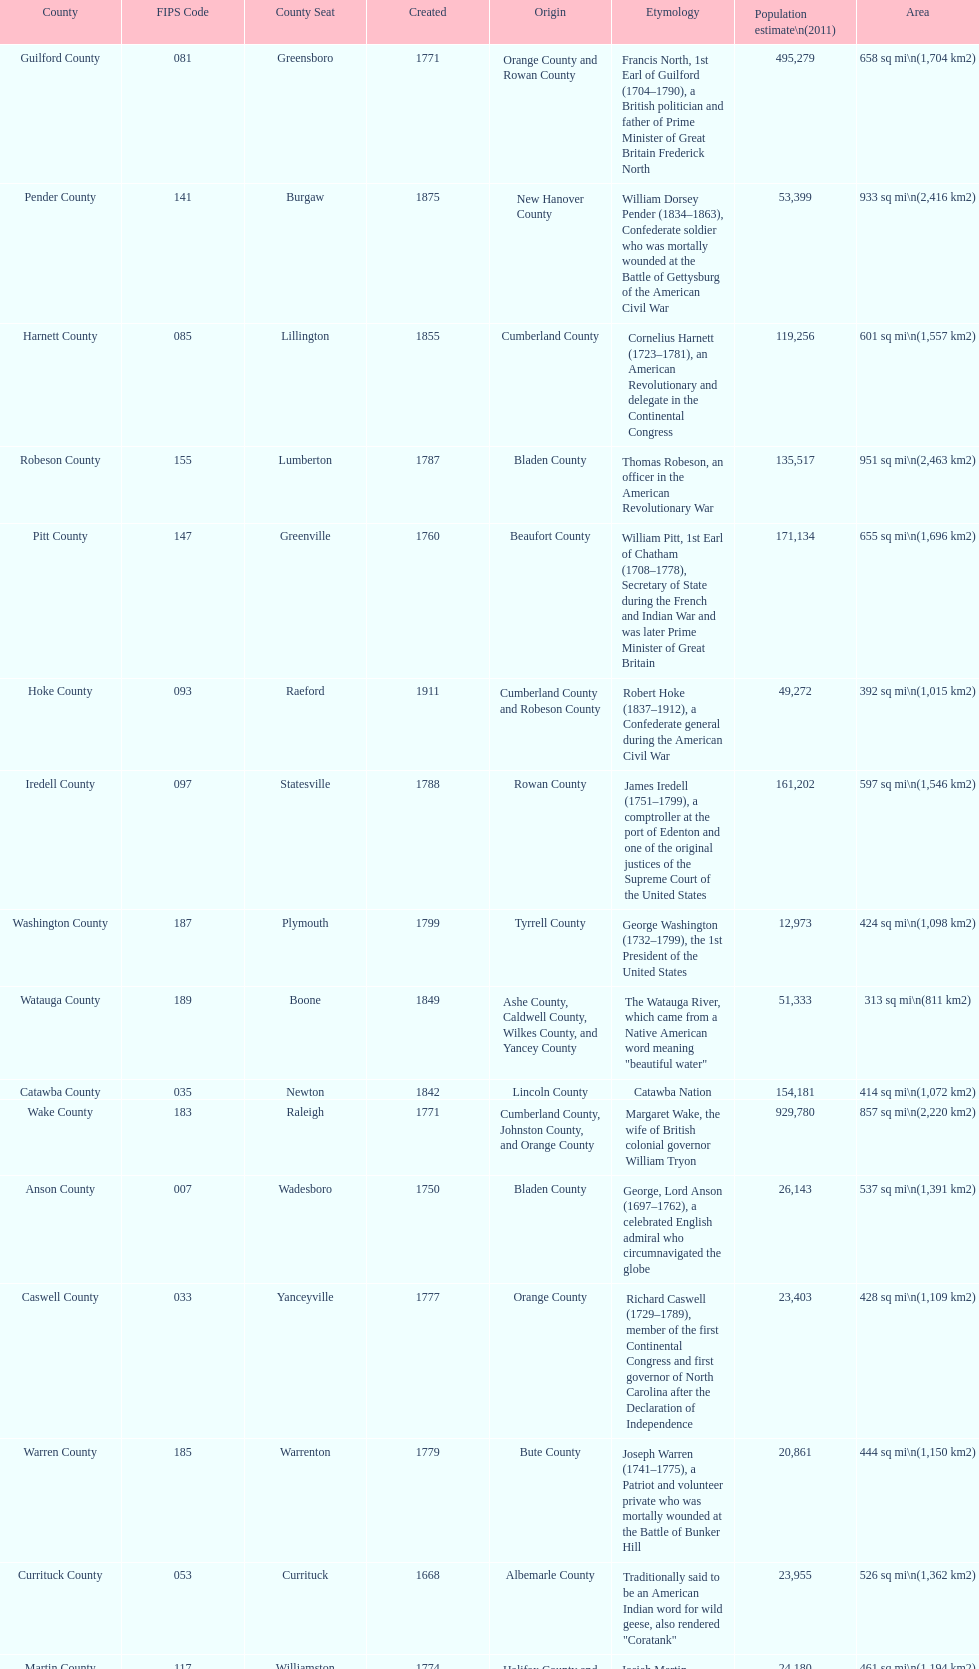Other than mecklenburg which county has the largest population? Wake County. 